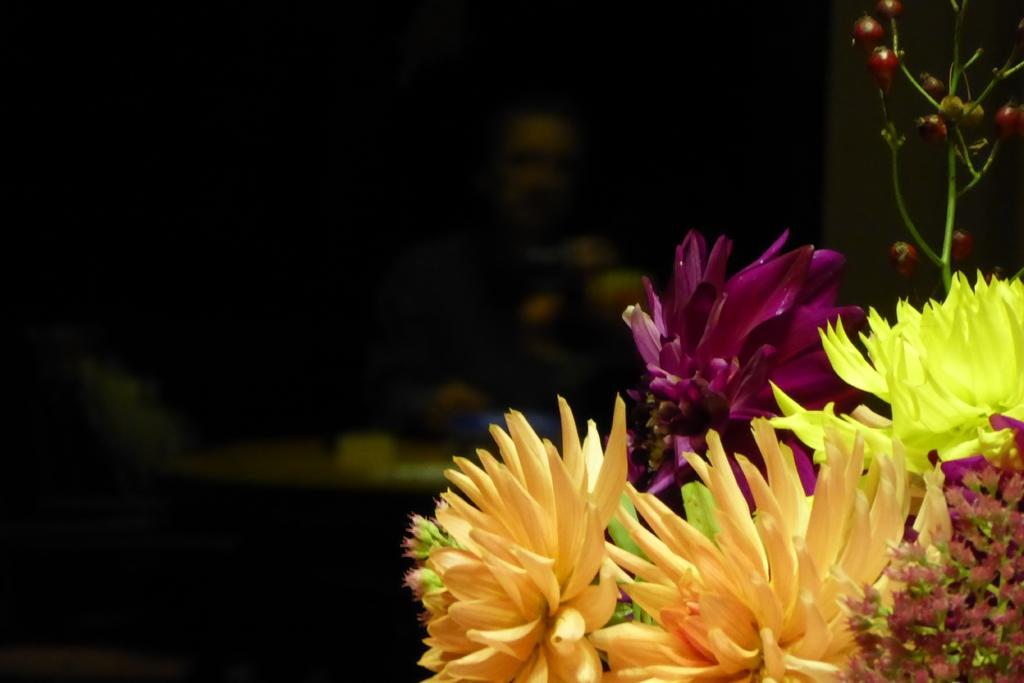What type of vegetation is in the front of the image? There are flowers in the front of the image. Can you describe the person in the background of the image? Unfortunately, the person in the background is not clearly visible, so we cannot describe them. What is the color of the background in the image? The background of the image is dark. What type of feast is being prepared in the image? There is no indication of a feast or any food preparation in the image. How does the acoustics of the room affect the person in the background? There is no information about the room's acoustics or how it might affect the person in the background. 